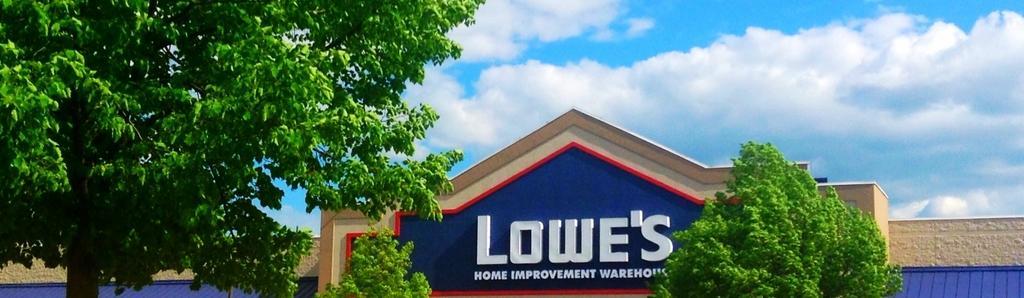How would you summarize this image in a sentence or two? In this picture we can see a building with a name on it, trees and in the background we can see the sky with clouds. 